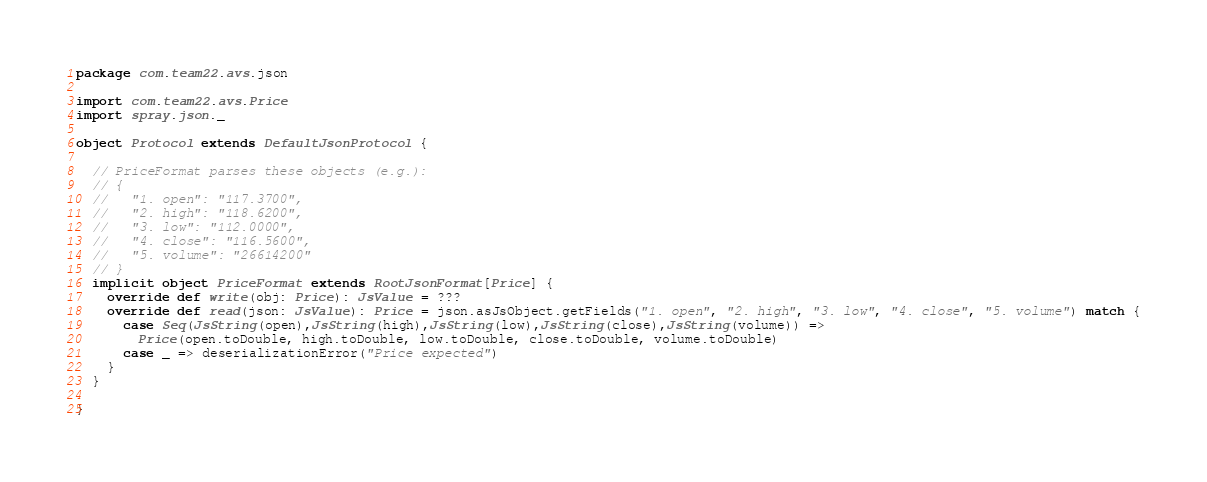<code> <loc_0><loc_0><loc_500><loc_500><_Scala_>package com.team22.avs.json

import com.team22.avs.Price
import spray.json._

object Protocol extends DefaultJsonProtocol {

  // PriceFormat parses these objects (e.g.):
  // {
  //   "1. open": "117.3700",
  //   "2. high": "118.6200",
  //   "3. low": "112.0000",
  //   "4. close": "116.5600",
  //   "5. volume": "26614200"
  // }
  implicit object PriceFormat extends RootJsonFormat[Price] {
    override def write(obj: Price): JsValue = ???
    override def read(json: JsValue): Price = json.asJsObject.getFields("1. open", "2. high", "3. low", "4. close", "5. volume") match {
      case Seq(JsString(open),JsString(high),JsString(low),JsString(close),JsString(volume)) =>
        Price(open.toDouble, high.toDouble, low.toDouble, close.toDouble, volume.toDouble)
      case _ => deserializationError("Price expected")
    }
  }

}
</code> 